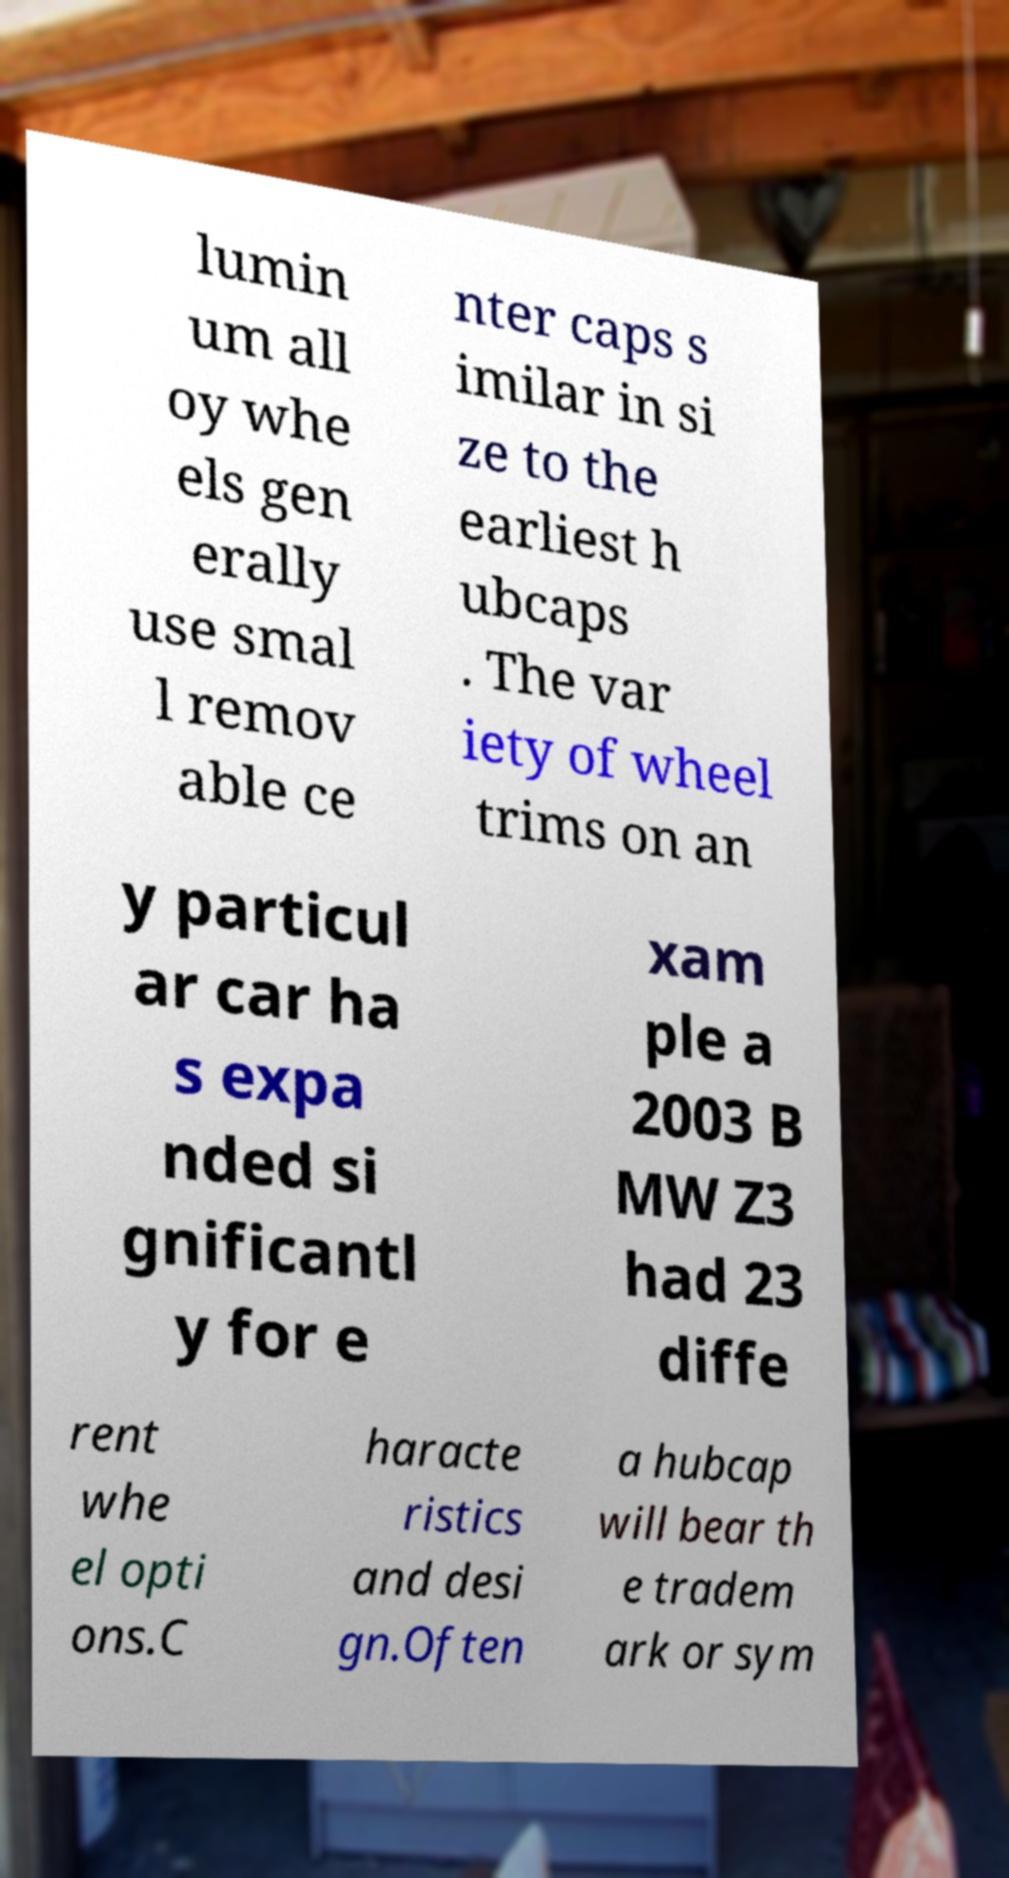Please read and relay the text visible in this image. What does it say? lumin um all oy whe els gen erally use smal l remov able ce nter caps s imilar in si ze to the earliest h ubcaps . The var iety of wheel trims on an y particul ar car ha s expa nded si gnificantl y for e xam ple a 2003 B MW Z3 had 23 diffe rent whe el opti ons.C haracte ristics and desi gn.Often a hubcap will bear th e tradem ark or sym 